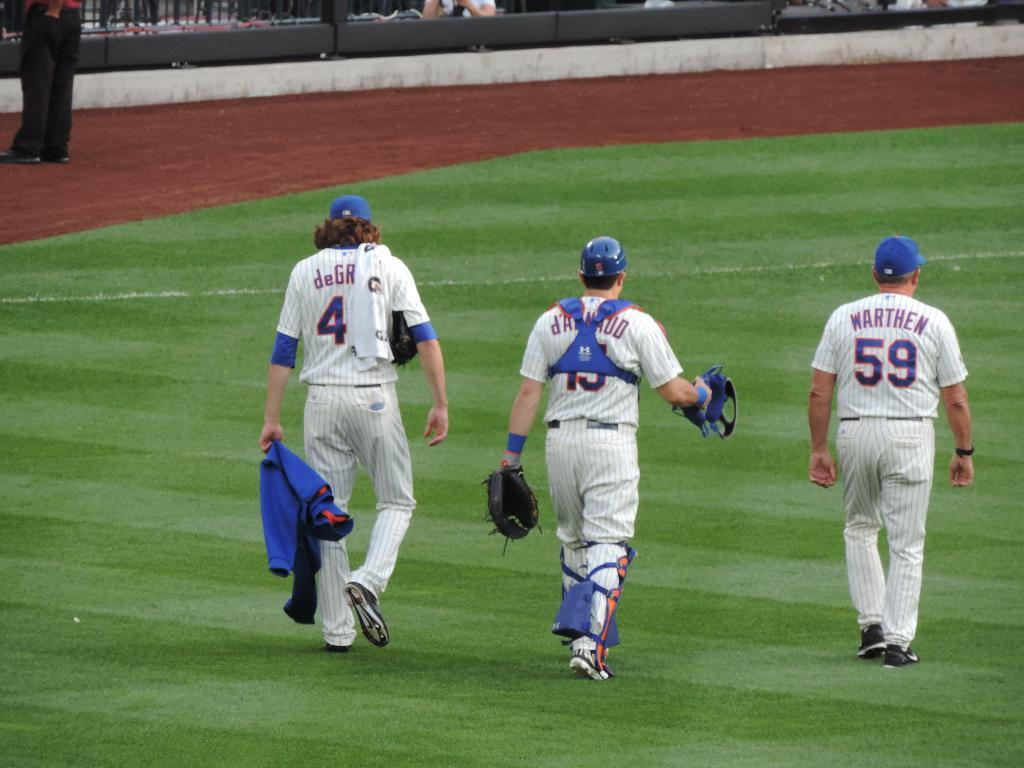<image>
Present a compact description of the photo's key features. baseball players 4, 15 and 59 walking off the field 